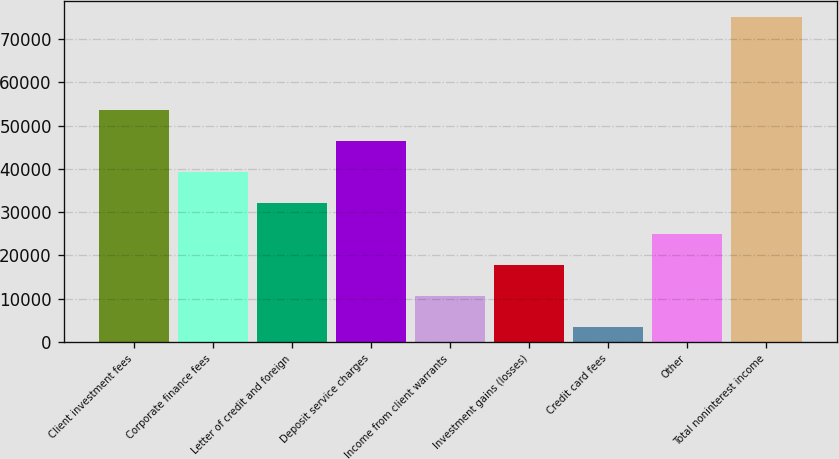<chart> <loc_0><loc_0><loc_500><loc_500><bar_chart><fcel>Client investment fees<fcel>Corporate finance fees<fcel>Letter of credit and foreign<fcel>Deposit service charges<fcel>Income from client warrants<fcel>Investment gains (losses)<fcel>Credit card fees<fcel>Other<fcel>Total noninterest income<nl><fcel>53571.3<fcel>39245.5<fcel>32082.6<fcel>46408.4<fcel>10593.9<fcel>17756.8<fcel>3431<fcel>24919.7<fcel>75060<nl></chart> 